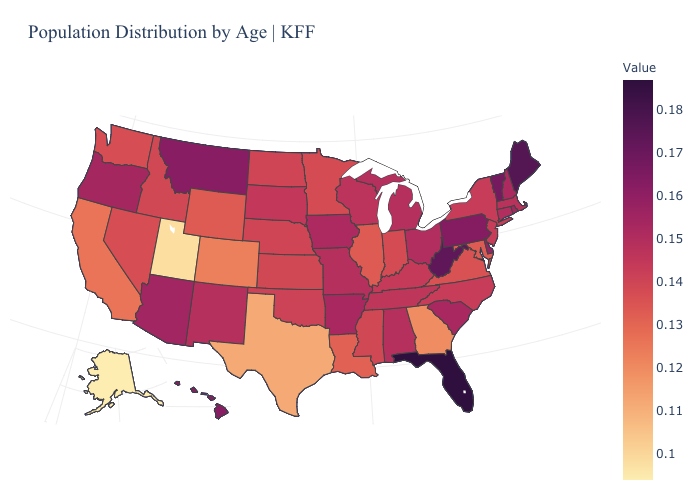Does South Carolina have a lower value than Pennsylvania?
Answer briefly. Yes. Which states hav the highest value in the Northeast?
Answer briefly. Maine. Which states have the highest value in the USA?
Concise answer only. Florida. 